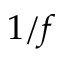Convert formula to latex. <formula><loc_0><loc_0><loc_500><loc_500>1 / f</formula> 